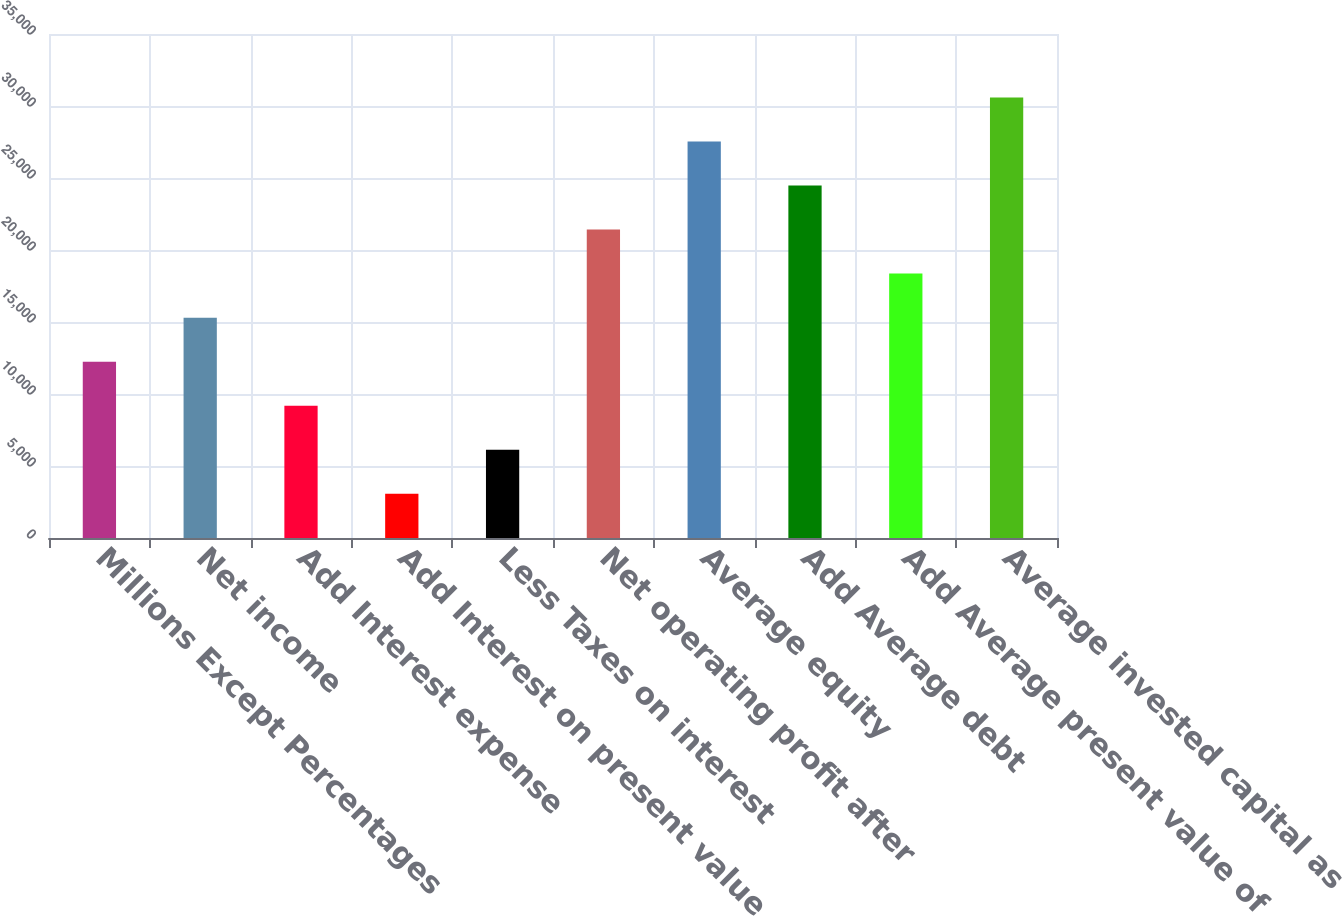Convert chart to OTSL. <chart><loc_0><loc_0><loc_500><loc_500><bar_chart><fcel>Millions Except Percentages<fcel>Net income<fcel>Add Interest expense<fcel>Add Interest on present value<fcel>Less Taxes on interest<fcel>Net operating profit after<fcel>Average equity<fcel>Add Average debt<fcel>Add Average present value of<fcel>Average invested capital as<nl><fcel>12245.4<fcel>15303.7<fcel>9187.18<fcel>3070.66<fcel>6128.92<fcel>21420.2<fcel>27536.7<fcel>24478.5<fcel>18362<fcel>30595<nl></chart> 